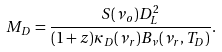<formula> <loc_0><loc_0><loc_500><loc_500>M _ { D } = \frac { S ( \nu _ { o } ) D ^ { 2 } _ { L } } { ( 1 + z ) \kappa _ { D } ( \nu _ { r } ) B _ { \nu } ( \nu _ { r } , T _ { D } ) } .</formula> 